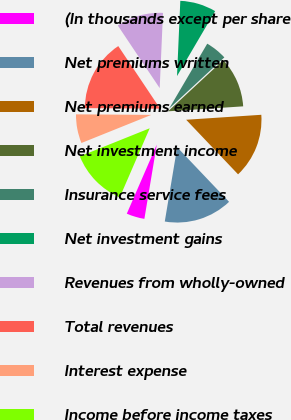<chart> <loc_0><loc_0><loc_500><loc_500><pie_chart><fcel>(In thousands except per share<fcel>Net premiums written<fcel>Net premiums earned<fcel>Net investment income<fcel>Insurance service fees<fcel>Net investment gains<fcel>Revenues from wholly-owned<fcel>Total revenues<fcel>Interest expense<fcel>Income before income taxes<nl><fcel>3.88%<fcel>14.73%<fcel>13.95%<fcel>10.85%<fcel>4.65%<fcel>7.75%<fcel>10.08%<fcel>15.5%<fcel>6.2%<fcel>12.4%<nl></chart> 